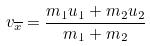Convert formula to latex. <formula><loc_0><loc_0><loc_500><loc_500>v _ { \overline { x } } = \frac { m _ { 1 } u _ { 1 } + m _ { 2 } u _ { 2 } } { m _ { 1 } + m _ { 2 } }</formula> 